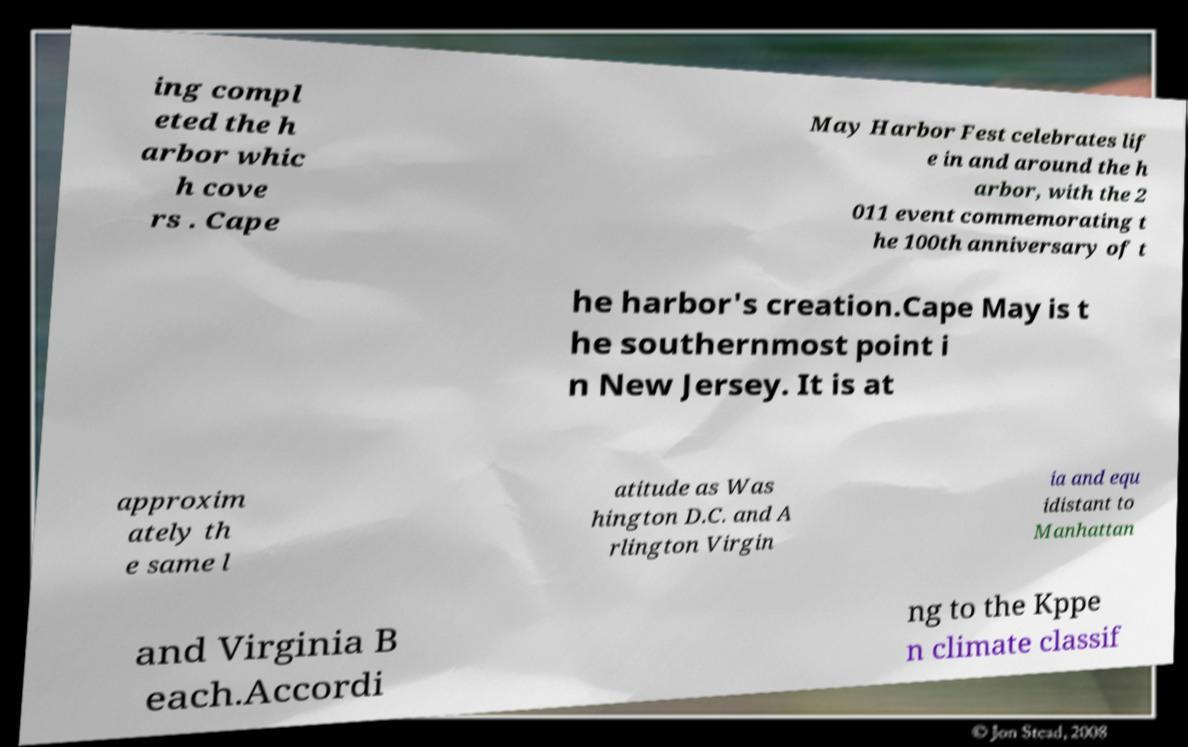Can you read and provide the text displayed in the image?This photo seems to have some interesting text. Can you extract and type it out for me? ing compl eted the h arbor whic h cove rs . Cape May Harbor Fest celebrates lif e in and around the h arbor, with the 2 011 event commemorating t he 100th anniversary of t he harbor's creation.Cape May is t he southernmost point i n New Jersey. It is at approxim ately th e same l atitude as Was hington D.C. and A rlington Virgin ia and equ idistant to Manhattan and Virginia B each.Accordi ng to the Kppe n climate classif 